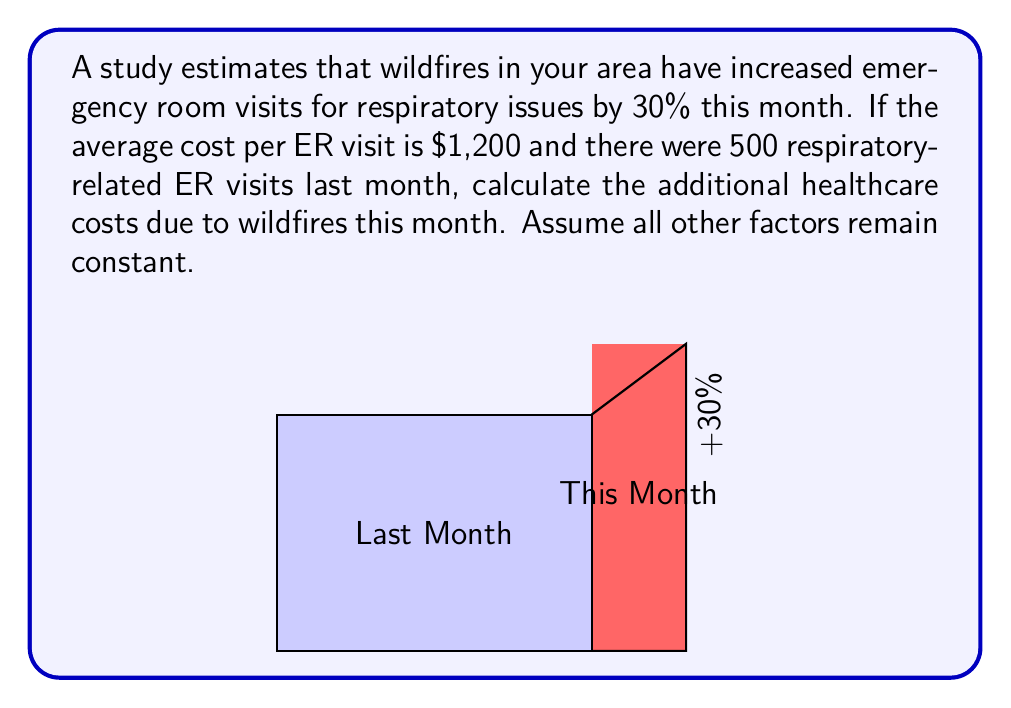What is the answer to this math problem? Let's approach this step-by-step:

1) First, we need to calculate the number of ER visits this month:
   - Last month's visits: 500
   - Increase: 30% = 0.30
   - Additional visits: $500 \times 0.30 = 150$
   - Total visits this month: $500 + 150 = 650$

2) Now, we calculate the total cost for this month's visits:
   $$ \text{Total Cost} = \text{Number of Visits} \times \text{Cost per Visit} $$
   $$ \text{Total Cost} = 650 \times \$1,200 = \$780,000 $$

3) To find the additional cost due to wildfires, we subtract last month's total cost:
   - Last month's total cost: $500 \times \$1,200 = \$600,000$
   - Additional cost: $\$780,000 - \$600,000 = \$180,000$

Therefore, the additional healthcare costs due to wildfires this month are $180,000.
Answer: $180,000 